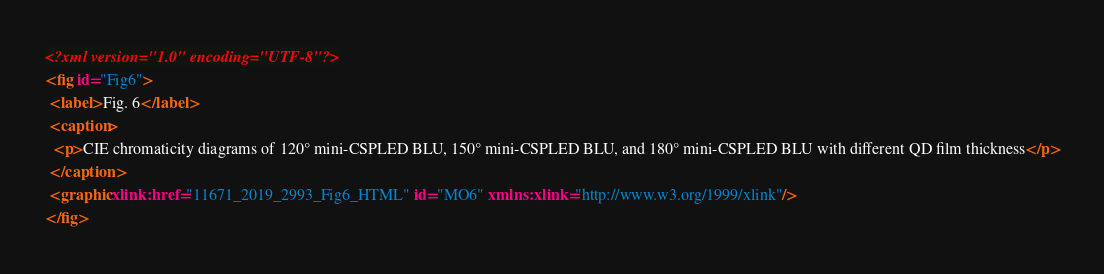<code> <loc_0><loc_0><loc_500><loc_500><_XML_><?xml version="1.0" encoding="UTF-8"?>
<fig id="Fig6">
 <label>Fig. 6</label>
 <caption>
  <p>CIE chromaticity diagrams of 120° mini-CSPLED BLU, 150° mini-CSPLED BLU, and 180° mini-CSPLED BLU with different QD film thickness</p>
 </caption>
 <graphic xlink:href="11671_2019_2993_Fig6_HTML" id="MO6" xmlns:xlink="http://www.w3.org/1999/xlink"/>
</fig>
</code> 